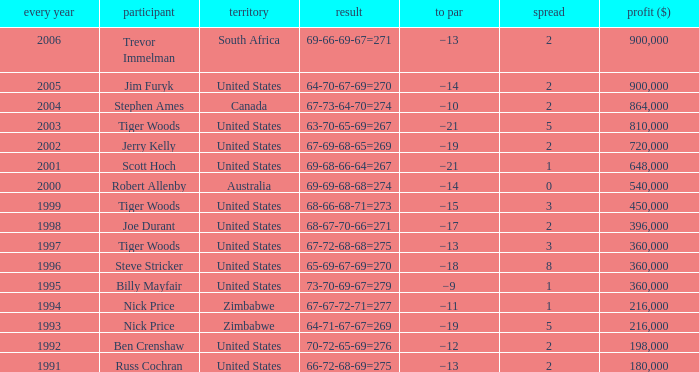Which To Par has Earnings ($) larger than 360,000, and a Year larger than 1998, and a Country of united states, and a Score of 69-68-66-64=267? −21. 